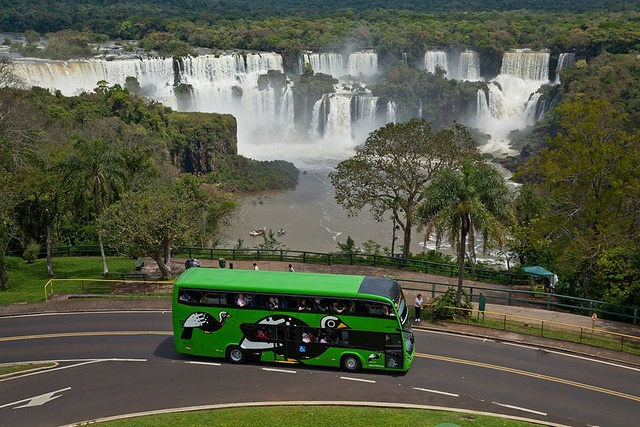Describe the objects in this image and their specific colors. I can see bus in purple, black, darkgreen, and lightgreen tones, people in purple, black, gray, and darkgreen tones, umbrella in purple, black, and teal tones, people in purple, black, gray, darkgray, and maroon tones, and people in purple, black, gray, darkgray, and maroon tones in this image. 